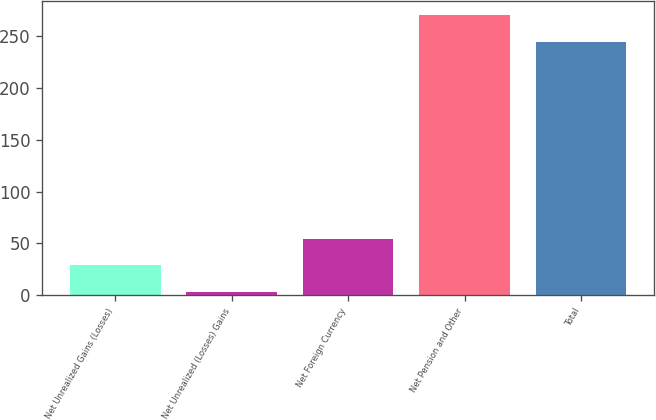Convert chart to OTSL. <chart><loc_0><loc_0><loc_500><loc_500><bar_chart><fcel>Net Unrealized Gains (Losses)<fcel>Net Unrealized (Losses) Gains<fcel>Net Foreign Currency<fcel>Net Pension and Other<fcel>Total<nl><fcel>28.64<fcel>2.9<fcel>54.38<fcel>270.04<fcel>244.3<nl></chart> 